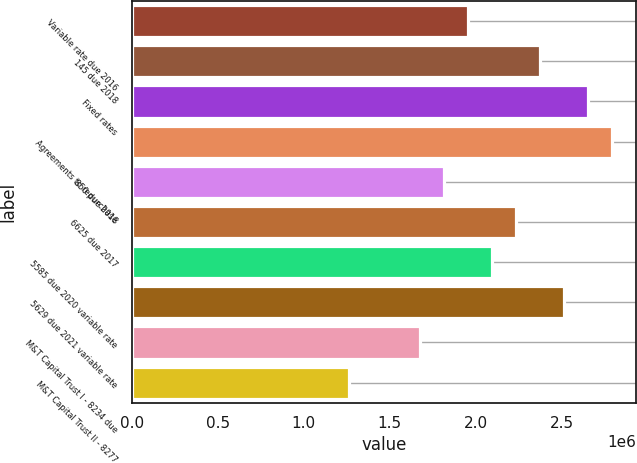Convert chart. <chart><loc_0><loc_0><loc_500><loc_500><bar_chart><fcel>Variable rate due 2016<fcel>145 due 2018<fcel>Fixed rates<fcel>Agreements to repurchase<fcel>850 due 2018<fcel>6625 due 2017<fcel>5585 due 2020 variable rate<fcel>5629 due 2021 variable rate<fcel>M&T Capital Trust I - 8234 due<fcel>M&T Capital Trust II - 8277<nl><fcel>1.95738e+06<fcel>2.37542e+06<fcel>2.6541e+06<fcel>2.79345e+06<fcel>1.81804e+06<fcel>2.23607e+06<fcel>2.09672e+06<fcel>2.51476e+06<fcel>1.67869e+06<fcel>1.26066e+06<nl></chart> 